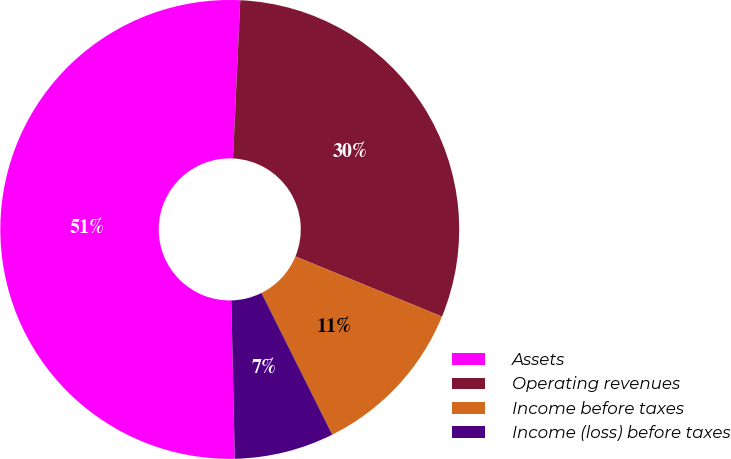<chart> <loc_0><loc_0><loc_500><loc_500><pie_chart><fcel>Assets<fcel>Operating revenues<fcel>Income before taxes<fcel>Income (loss) before taxes<nl><fcel>51.08%<fcel>30.47%<fcel>11.42%<fcel>7.02%<nl></chart> 